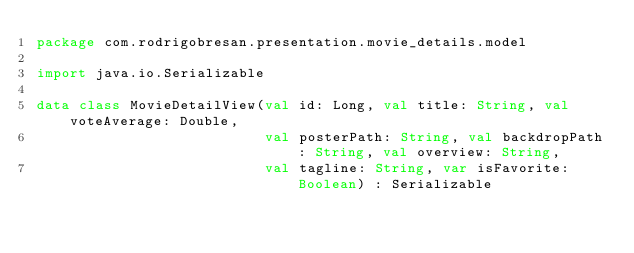<code> <loc_0><loc_0><loc_500><loc_500><_Kotlin_>package com.rodrigobresan.presentation.movie_details.model

import java.io.Serializable

data class MovieDetailView(val id: Long, val title: String, val voteAverage: Double,
                           val posterPath: String, val backdropPath: String, val overview: String,
                           val tagline: String, var isFavorite: Boolean) : Serializable</code> 